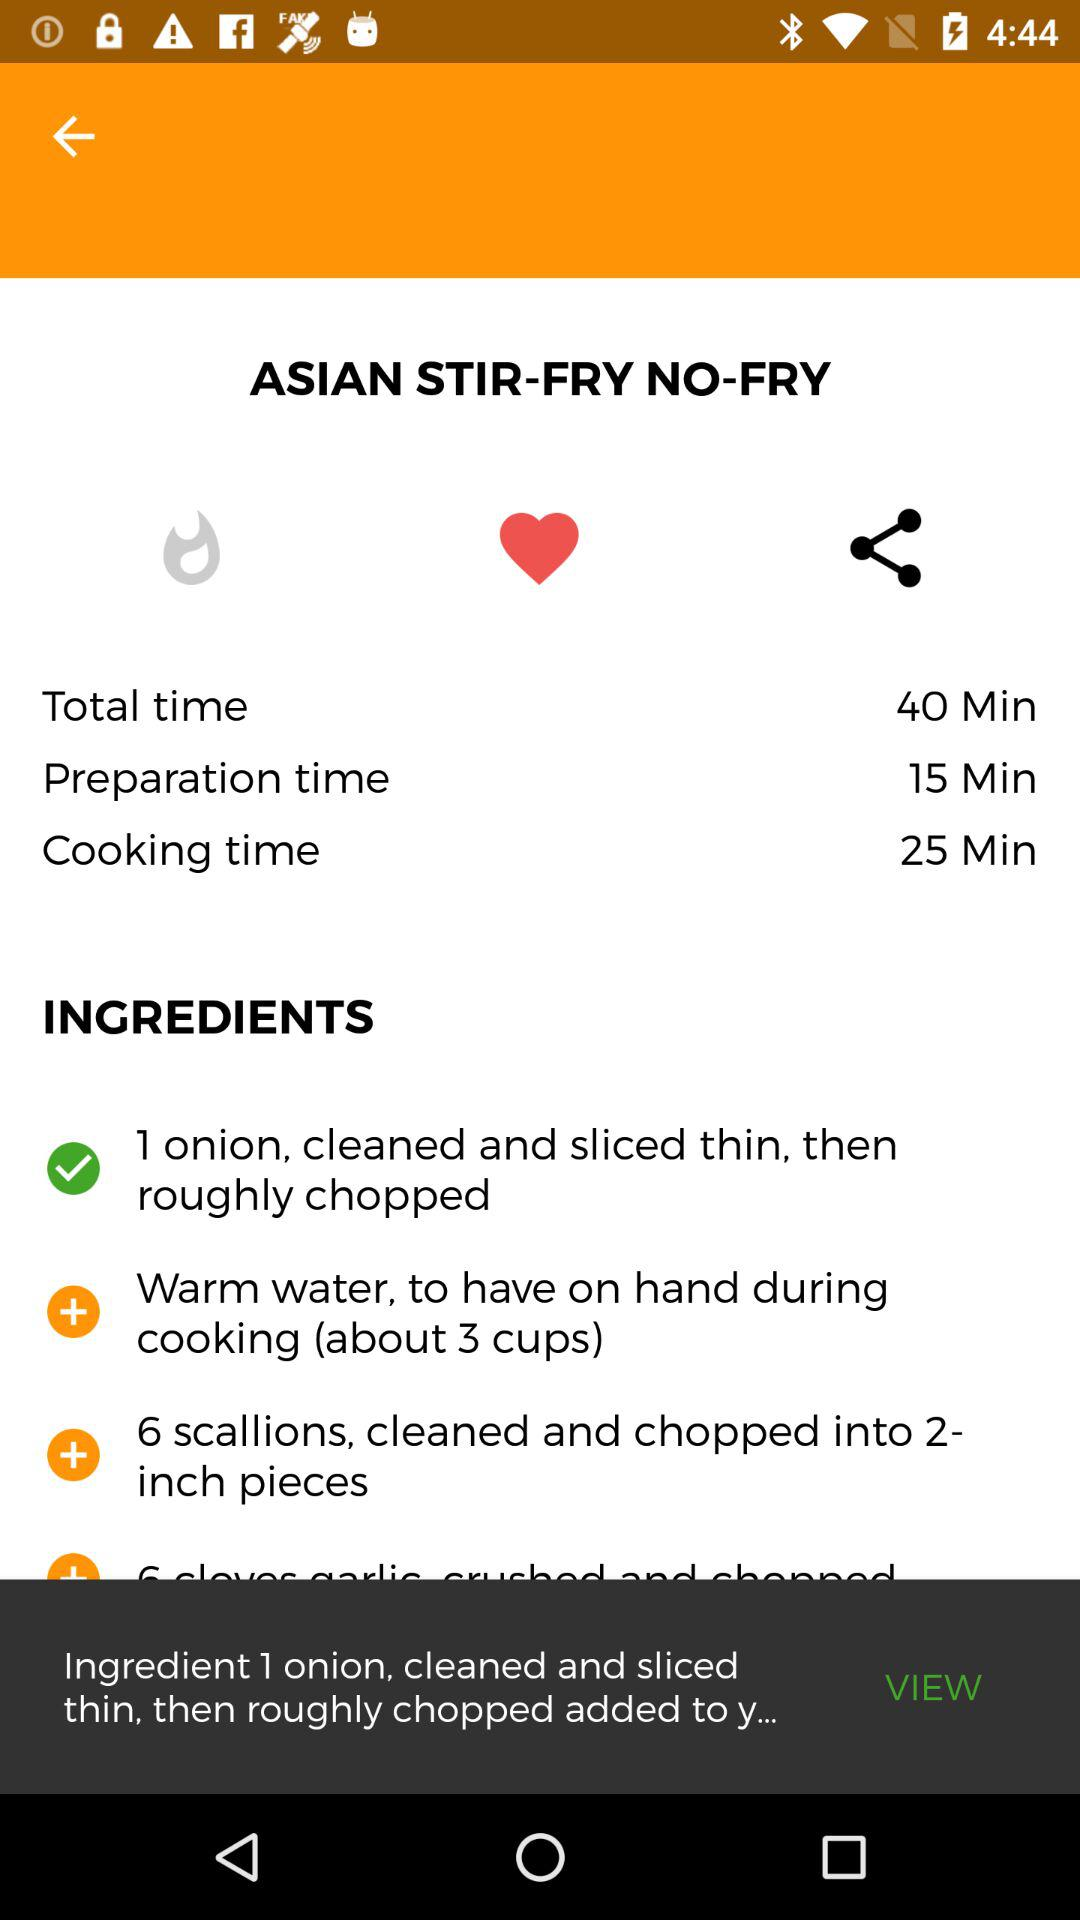What is the cooking time? The cooking time is 25 minutes. 